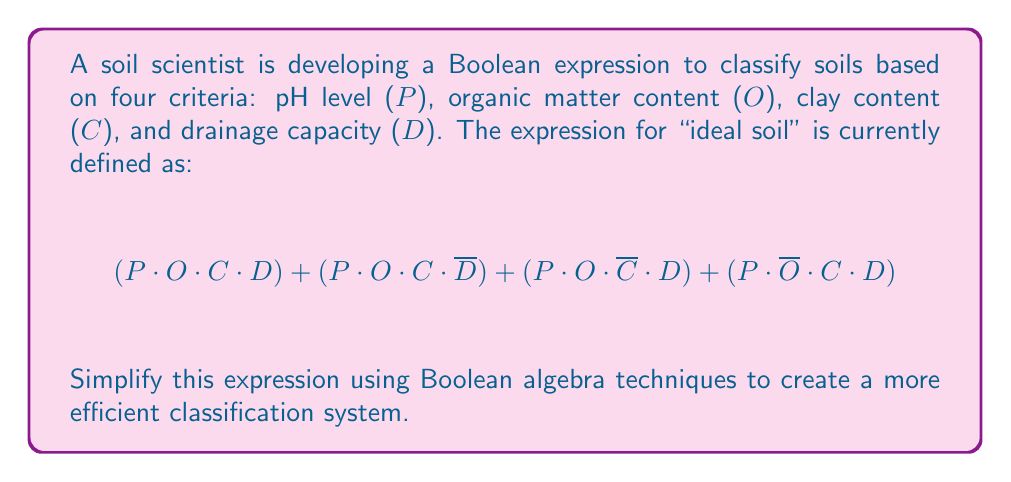Can you solve this math problem? Let's simplify the given Boolean expression step by step:

1) First, we can factor out the common terms:

   $P \cdot [(O \cdot C \cdot D) + (O \cdot C \cdot \overline{D}) + (O \cdot \overline{C} \cdot D) + (\overline{O} \cdot C \cdot D)]$

2) Within the brackets, we can further factor out common terms:

   $P \cdot [O \cdot C \cdot (D + \overline{D}) + O \cdot \overline{C} \cdot D + \overline{O} \cdot C \cdot D]$

3) Simplify using the Boolean identity $X + \overline{X} = 1$:

   $P \cdot [O \cdot C \cdot 1 + O \cdot \overline{C} \cdot D + \overline{O} \cdot C \cdot D]$

4) Simplify further:

   $P \cdot [O \cdot C + O \cdot \overline{C} \cdot D + \overline{O} \cdot C \cdot D]$

5) Factor out D from the last two terms:

   $P \cdot [O \cdot C + D \cdot (O \cdot \overline{C} + \overline{O} \cdot C)]$

6) The expression $(O \cdot \overline{C} + \overline{O} \cdot C)$ is the exclusive OR operation, which can be written as $O \oplus C$.

7) Therefore, our final simplified expression is:

   $P \cdot (O \cdot C + D \cdot (O \oplus C))$

This simplified expression is logically equivalent to the original but uses fewer operations, making it more efficient for soil classification.
Answer: $P \cdot (O \cdot C + D \cdot (O \oplus C))$ 